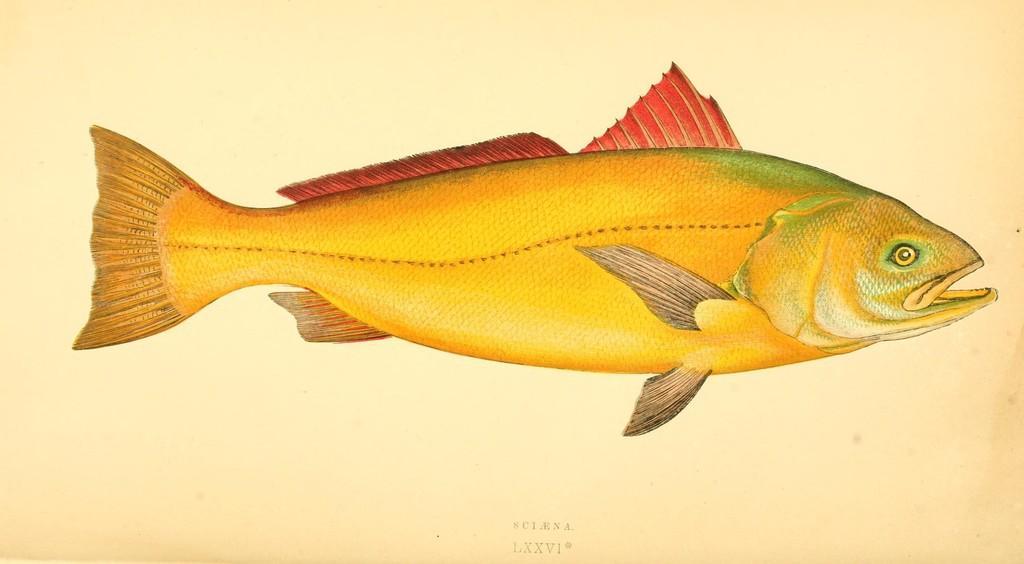Please provide a concise description of this image. In this picture I can see a paper, there is a diagram of a fish, there are roman numbers and letters on the paper. 